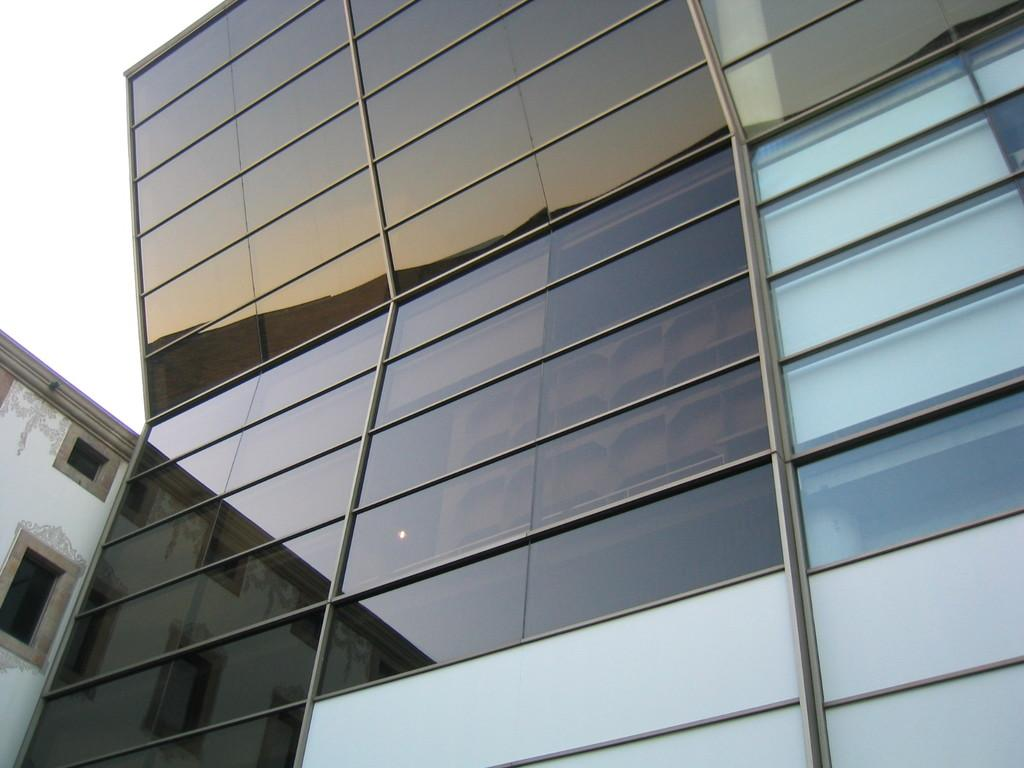What type of structure is shown in the image? The image is of a building. What material is used for the walls of the building? The building has glass walls. How many windows are visible on the side of the building? There are two windows on the side of the building. What color is the kite flying in front of the building? There is no kite present in the image; it only shows the building with glass walls and two windows on the side. 